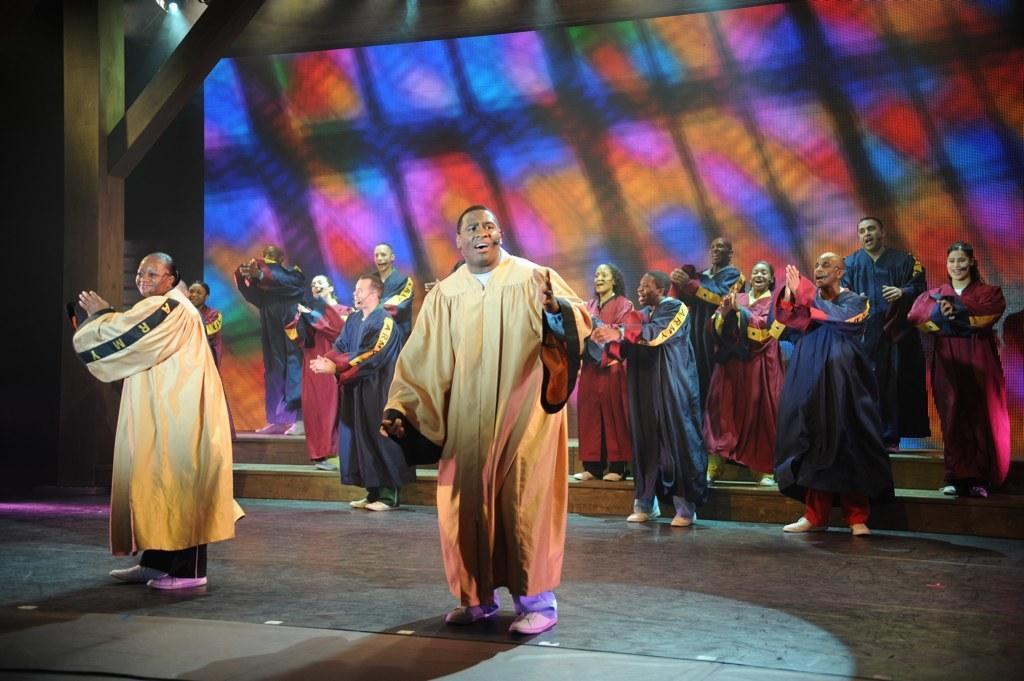Could you give a brief overview of what you see in this image? In this image there is a group of persons are performing on the stage as we can see in the middle of this image. There is a screen in the background. There is a floor in the bottom of this image. 